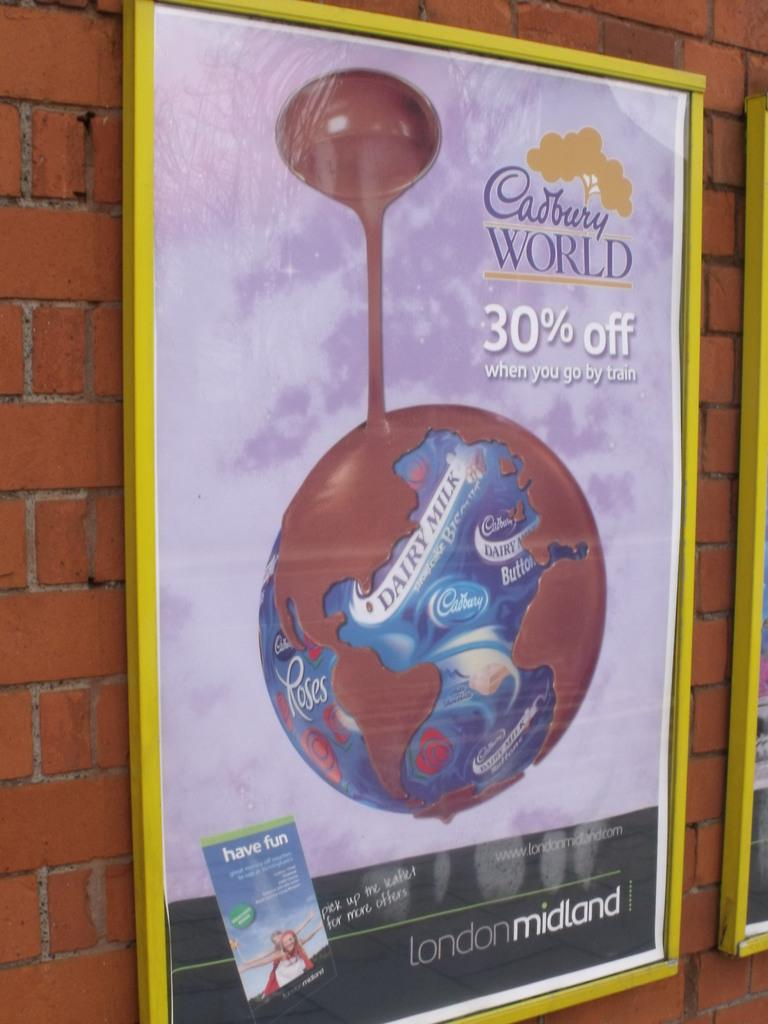What type of structure is visible in the image? There is a brick wall in the image. What is featured on the board in the image? There is a board with a Cadbury advertisement in the image. What type of thrill can be experienced while riding in a carriage in the image? There is no carriage present in the image, and therefore no such experience can be observed. What type of wine is being advertised on the board in the image? There is no wine being advertised on the board in the image; it features a Cadbury advertisement. 